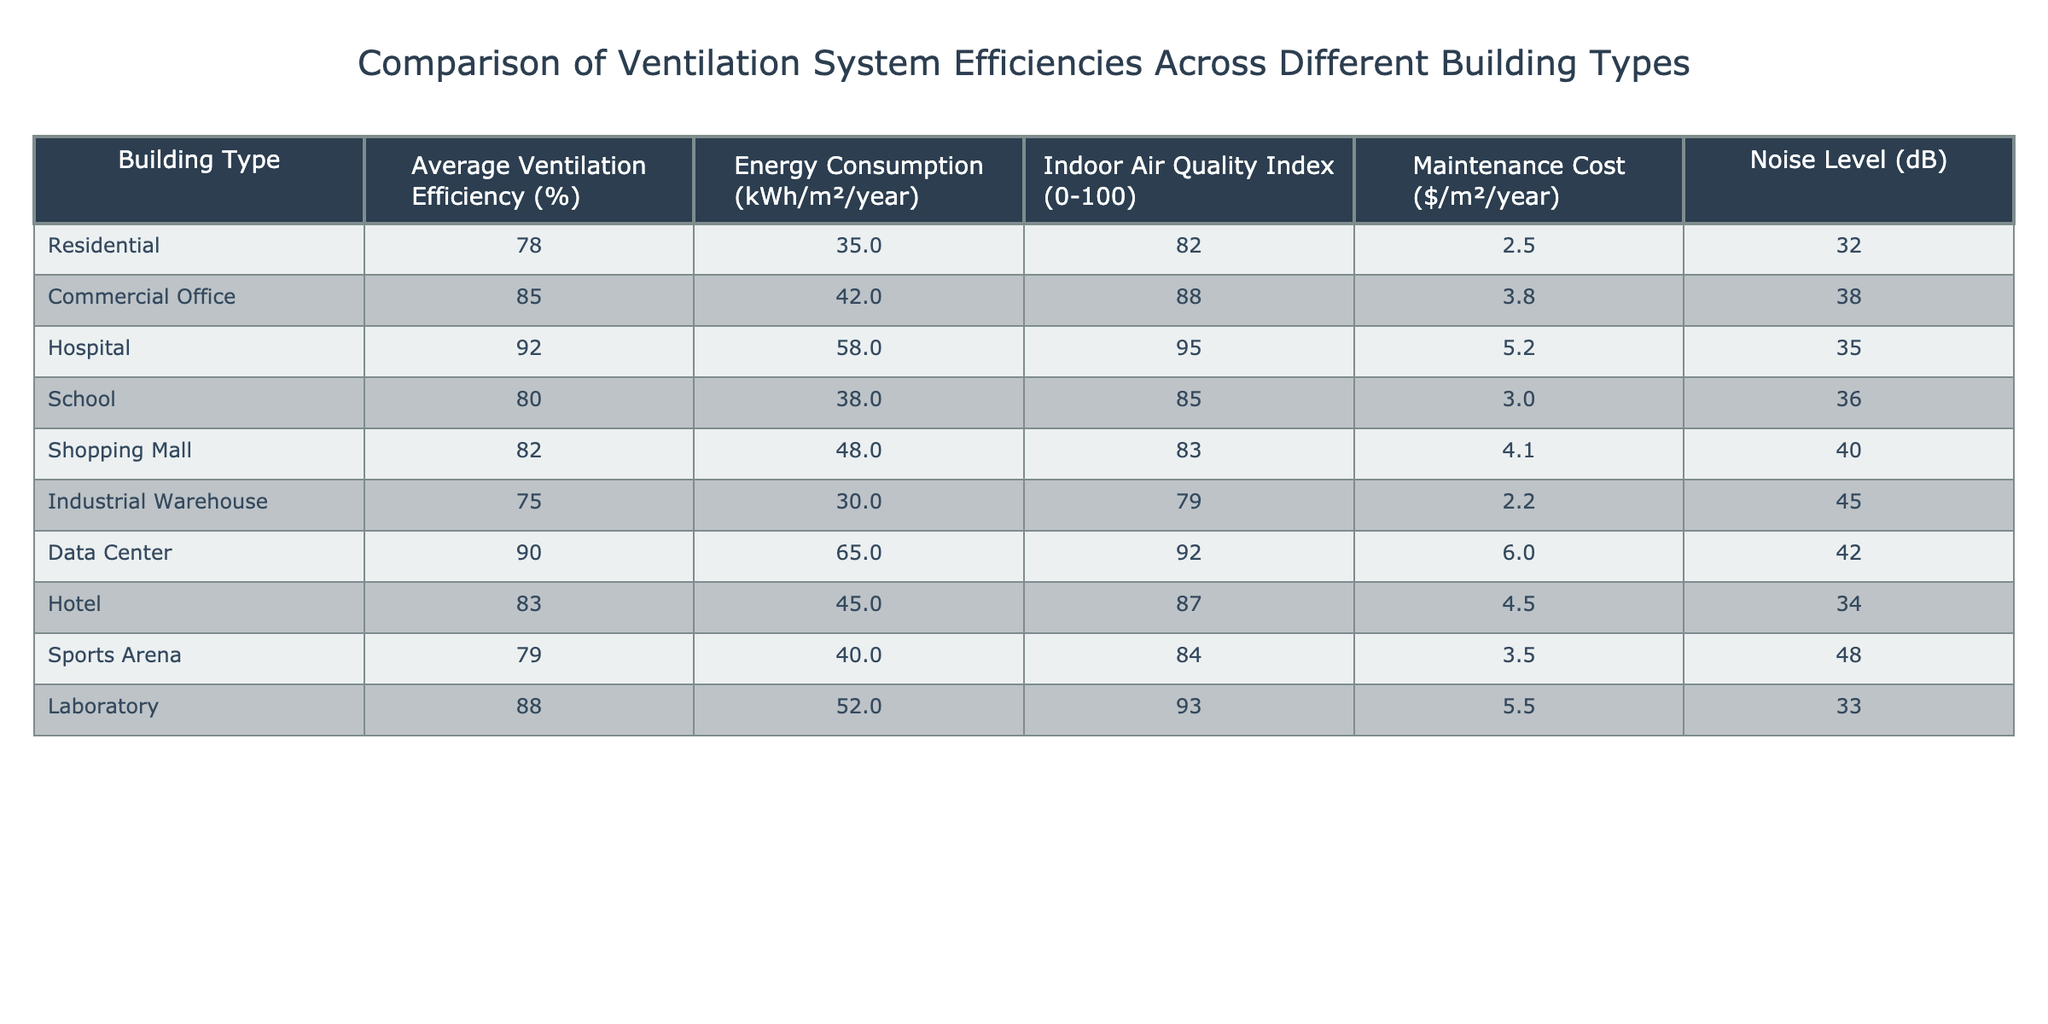What is the average ventilation efficiency for all building types? To find the average ventilation efficiency, sum the efficiencies of all building types (78 + 85 + 92 + 80 + 82 + 75 + 90 + 83 + 79 + 88) =  927. There are 10 building types, so the average is 927/10 = 92.7.
Answer: 92.7% Which building type has the highest maintenance cost? Looking at the maintenance cost column, the hospital has the highest value at $5.2/m²/year.
Answer: Hospital What is the indoor air quality index for a data center? The indoor air quality index for a data center is directly listed in the table as 92.
Answer: 92 Is the energy consumption for an industrial warehouse higher than for a residential building? The energy consumption for an industrial warehouse is 30 kWh/m²/year, while the residential building has 35 kWh/m²/year, meaning the residential building has a higher energy consumption.
Answer: No What is the total energy consumption for all building types combined? To find the total, sum up the energy consumption values: (35 + 42 + 58 + 38 + 48 + 30 + 65 + 45 + 40 + 52) =  403 kWh/m²/year.
Answer: 403 kWh/m²/year Which building type has the lowest noise level? The industrial warehouse has the lowest noise level at 45 dB as per the noise level column.
Answer: Industrial Warehouse How does the average indoor air quality index compare to the average maintenance cost across all building types? The average indoor air quality index is calculated as (82 + 88 + 95 + 85 + 83 + 79 + 92 + 87 + 84 + 93) =  87.2, and the average maintenance cost is calculated as ($2.5 + $3.8 + $5.2 + $3.0 + $4.1 + $2.2 + $6.0 + $4.5 + $3.5 + $5.5) = $4.1. Comparing the two, the average indoor air quality index is 87.2, while the average maintenance cost is $4.1.
Answer: Higher indoor air quality index Are commercial offices more energy efficient than schools? The average ventilation efficiency for commercial offices is 85%, while for schools it is 80%. Hence, commercial offices are more energy efficient than schools.
Answer: Yes What is the difference in indoor air quality index between the hospital and the shopping mall? The hospital has an indoor air quality index of 95, while the shopping mall has 83; the difference is 95 - 83 = 12.
Answer: 12 